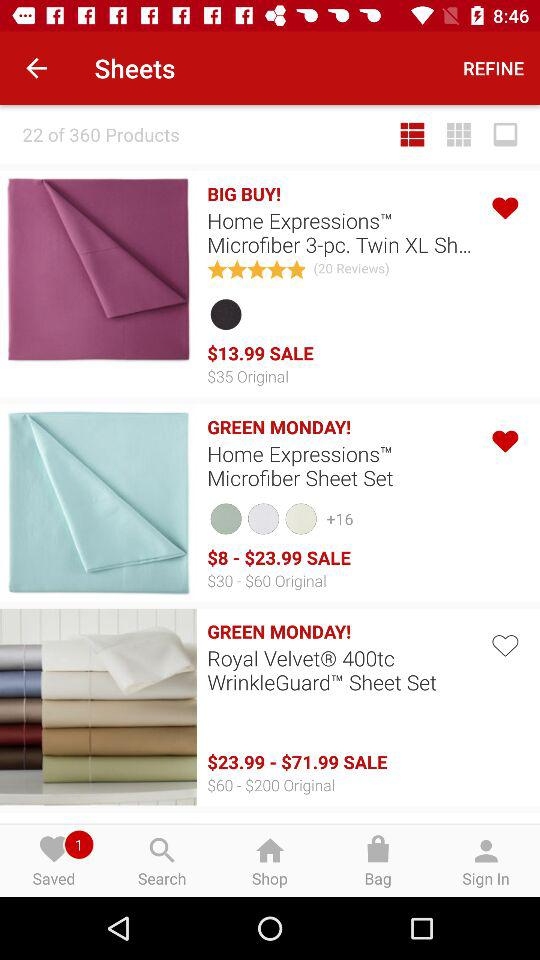Are there any saved products? There is 1 saved product. 